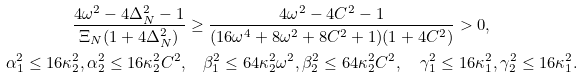<formula> <loc_0><loc_0><loc_500><loc_500>\frac { 4 \omega ^ { 2 } - 4 \Delta _ { N } ^ { 2 } - 1 } { \Xi _ { N } ( 1 + 4 \Delta _ { N } ^ { 2 } ) } & \geq \frac { 4 \omega ^ { 2 } - 4 C ^ { 2 } - 1 } { ( 1 6 \omega ^ { 4 } + 8 \omega ^ { 2 } + 8 C ^ { 2 } + 1 ) ( 1 + 4 C ^ { 2 } ) } > 0 , \\ \alpha _ { 1 } ^ { 2 } \leq 1 6 \kappa _ { 2 } ^ { 2 } , \alpha _ { 2 } ^ { 2 } \leq 1 6 \kappa _ { 2 } ^ { 2 } C ^ { 2 } , & \quad \beta _ { 1 } ^ { 2 } \leq 6 4 \kappa _ { 2 } ^ { 2 } \omega ^ { 2 } , \beta _ { 2 } ^ { 2 } \leq 6 4 \kappa _ { 2 } ^ { 2 } C ^ { 2 } , \quad \gamma _ { 1 } ^ { 2 } \leq 1 6 \kappa _ { 1 } ^ { 2 } , \gamma _ { 2 } ^ { 2 } \leq 1 6 \kappa _ { 1 } ^ { 2 } .</formula> 